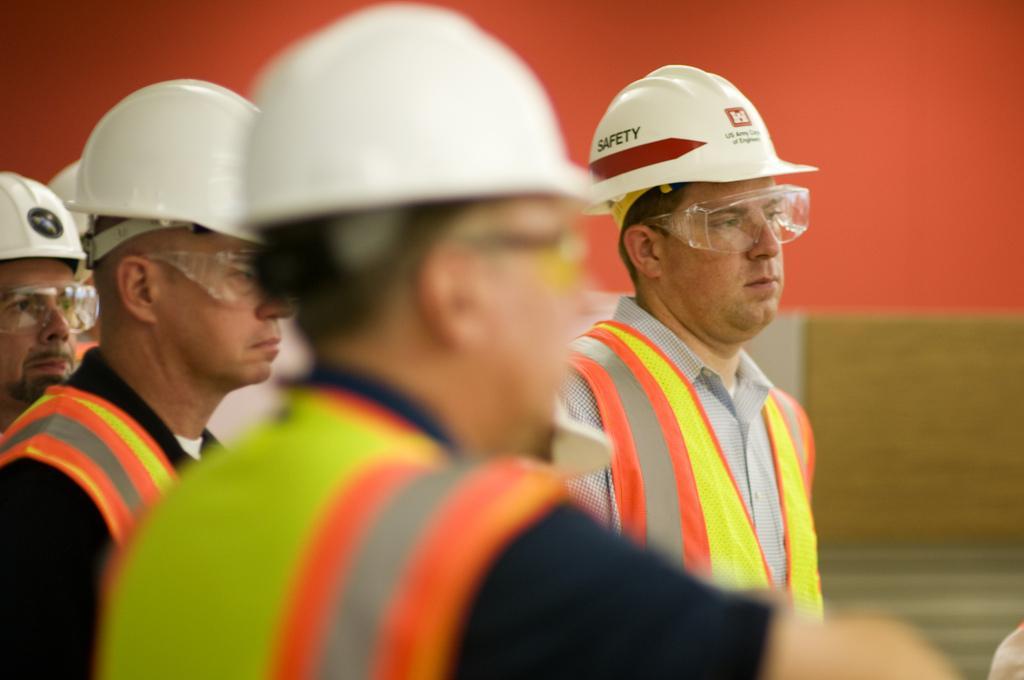Describe this image in one or two sentences. In this picture, there are group of men wearing jackets and white helmets. All of them are staring towards the right. In the background, there is a wall which is in orange and brown. 